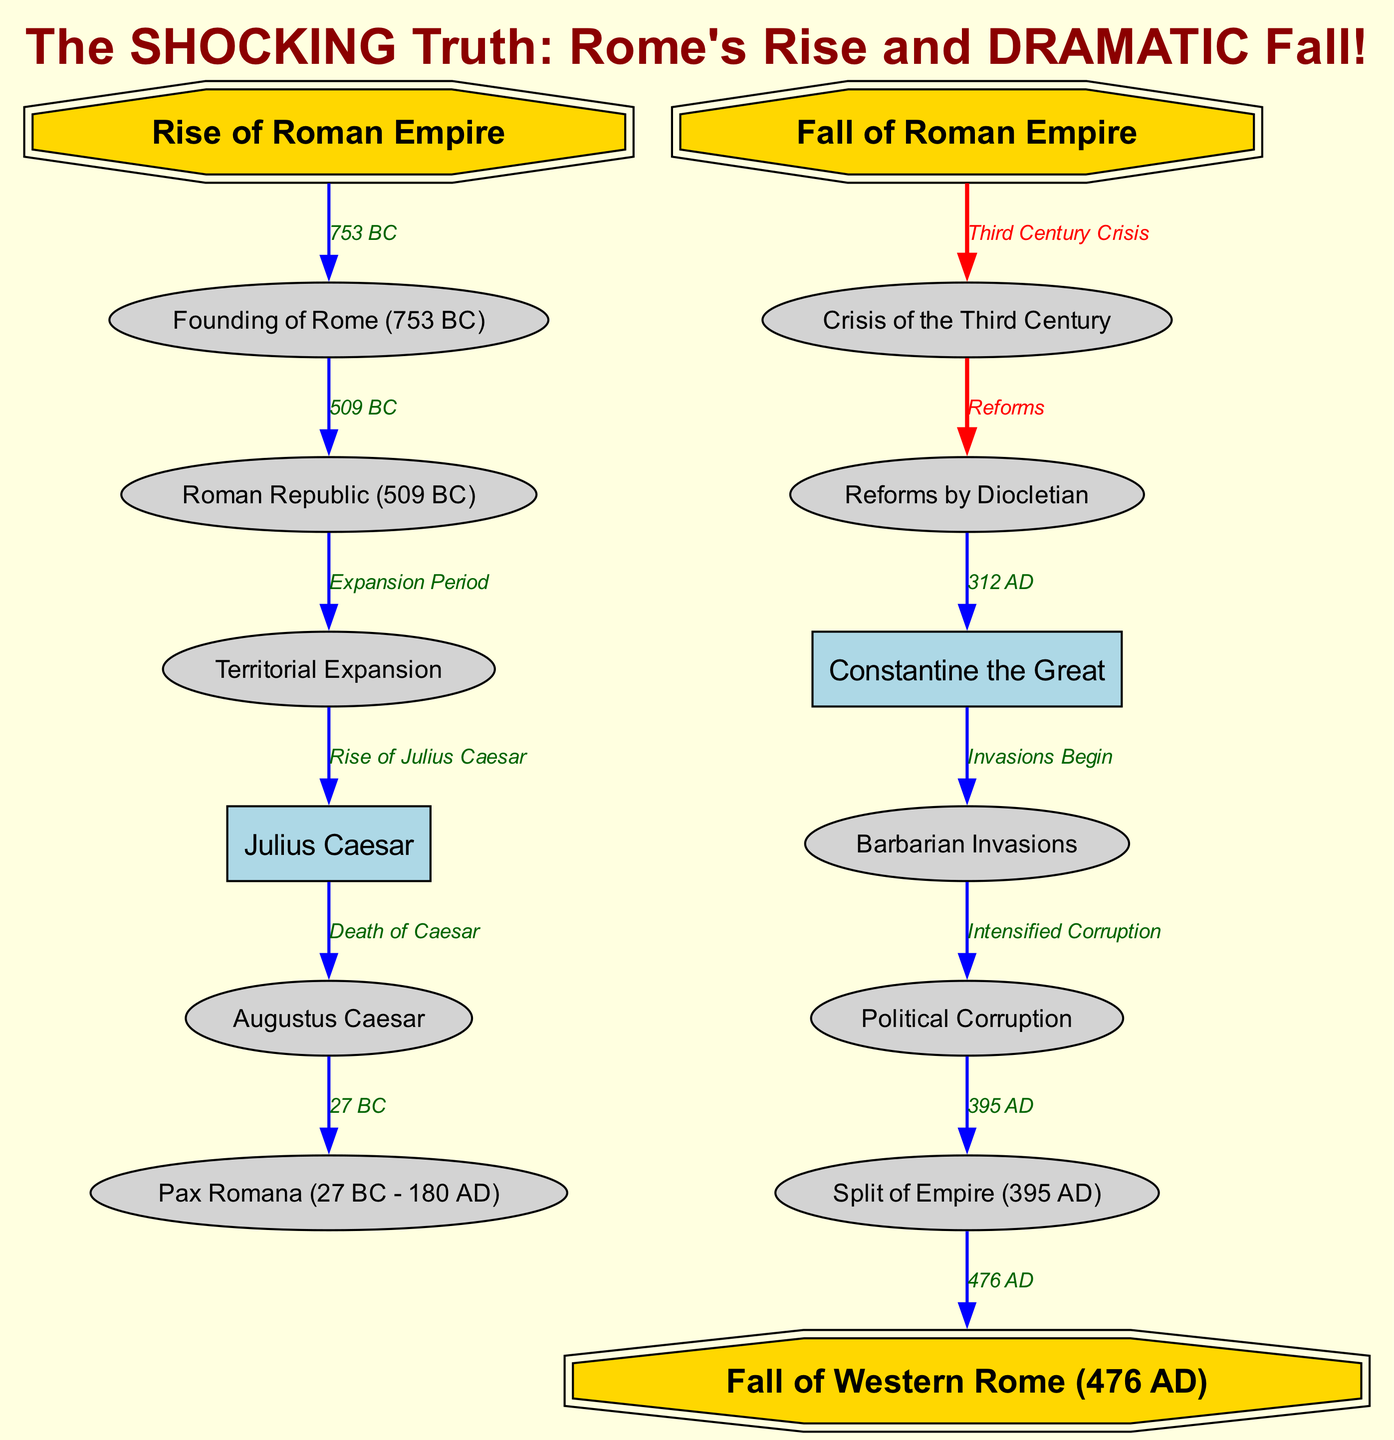What year was the founding of Rome? The node "Founding" has the label "Founding of Rome (753 BC)", which indicates the specific year of this event.
Answer: 753 BC What does the edge from "Caesar" to "Augustus" represent? The edge between these two nodes is labeled "Death of Caesar," which signifies a critical event leading to Augustus' rise.
Answer: Death of Caesar How many nodes are in the diagram? By counting the nodes in the provided data, there are a total of 13 nodes present in the diagram.
Answer: 13 How did the Roman Empire enter the "Crisis of the Third Century"? The diagram shows an edge from "Fall" to "Crisis," indicating that the transition into this crisis was due to the fall-related factors affecting the empire.
Answer: Fall What year did the Split of the Empire occur? The edge labeled "395 AD" connects to the node "Split," indicating that this was the year when the empire was divided.
Answer: 395 AD What event is indicated as leading to the Barbarian Invasions? The edge from "Constantine" to "Barbarians" is labeled "Invasions Begin," showing that this was the event that triggered the invasions.
Answer: Invasions Begin Which two nodes are connected by an edge labeled with "Third Century Crisis"? The "Fall" node connects to the "Crisis" node through the edge labeled with this phrase, indicating the relationship between them.
Answer: Fall and Crisis What is the final event indicated in the diagram regarding the Western Roman Empire? The last edge connects "Split" to "RomeFalls," suggesting that the final event marked in the diagram is the fall of Western Rome.
Answer: Fall of Western Rome 